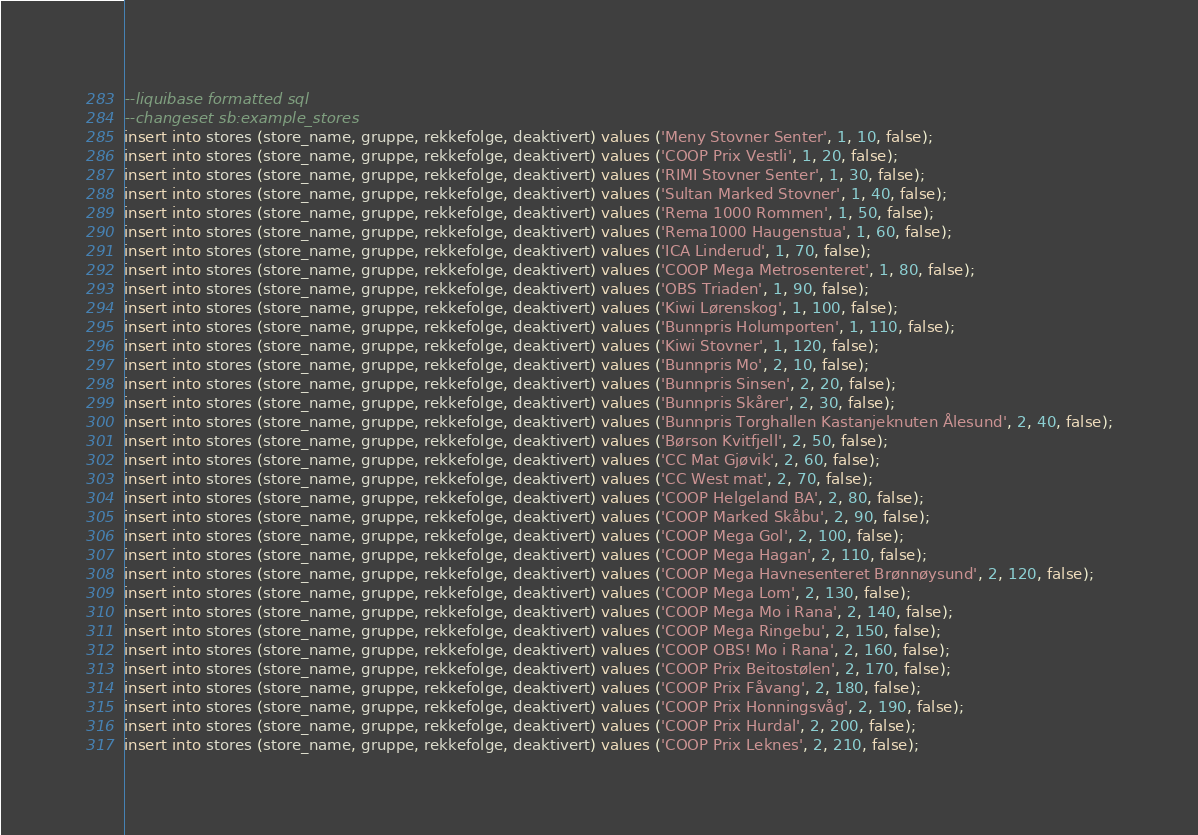Convert code to text. <code><loc_0><loc_0><loc_500><loc_500><_SQL_>--liquibase formatted sql
--changeset sb:example_stores
insert into stores (store_name, gruppe, rekkefolge, deaktivert) values ('Meny Stovner Senter', 1, 10, false);
insert into stores (store_name, gruppe, rekkefolge, deaktivert) values ('COOP Prix Vestli', 1, 20, false);
insert into stores (store_name, gruppe, rekkefolge, deaktivert) values ('RIMI Stovner Senter', 1, 30, false);
insert into stores (store_name, gruppe, rekkefolge, deaktivert) values ('Sultan Marked Stovner', 1, 40, false);
insert into stores (store_name, gruppe, rekkefolge, deaktivert) values ('Rema 1000 Rommen', 1, 50, false);
insert into stores (store_name, gruppe, rekkefolge, deaktivert) values ('Rema1000 Haugenstua', 1, 60, false);
insert into stores (store_name, gruppe, rekkefolge, deaktivert) values ('ICA Linderud', 1, 70, false);
insert into stores (store_name, gruppe, rekkefolge, deaktivert) values ('COOP Mega Metrosenteret', 1, 80, false);
insert into stores (store_name, gruppe, rekkefolge, deaktivert) values ('OBS Triaden', 1, 90, false);
insert into stores (store_name, gruppe, rekkefolge, deaktivert) values ('Kiwi Lørenskog', 1, 100, false);
insert into stores (store_name, gruppe, rekkefolge, deaktivert) values ('Bunnpris Holumporten', 1, 110, false);
insert into stores (store_name, gruppe, rekkefolge, deaktivert) values ('Kiwi Stovner', 1, 120, false);
insert into stores (store_name, gruppe, rekkefolge, deaktivert) values ('Bunnpris Mo', 2, 10, false);
insert into stores (store_name, gruppe, rekkefolge, deaktivert) values ('Bunnpris Sinsen', 2, 20, false);
insert into stores (store_name, gruppe, rekkefolge, deaktivert) values ('Bunnpris Skårer', 2, 30, false);
insert into stores (store_name, gruppe, rekkefolge, deaktivert) values ('Bunnpris Torghallen Kastanjeknuten Ålesund', 2, 40, false);
insert into stores (store_name, gruppe, rekkefolge, deaktivert) values ('Børson Kvitfjell', 2, 50, false);
insert into stores (store_name, gruppe, rekkefolge, deaktivert) values ('CC Mat Gjøvik', 2, 60, false);
insert into stores (store_name, gruppe, rekkefolge, deaktivert) values ('CC West mat', 2, 70, false);
insert into stores (store_name, gruppe, rekkefolge, deaktivert) values ('COOP Helgeland BA', 2, 80, false);
insert into stores (store_name, gruppe, rekkefolge, deaktivert) values ('COOP Marked Skåbu', 2, 90, false);
insert into stores (store_name, gruppe, rekkefolge, deaktivert) values ('COOP Mega Gol', 2, 100, false);
insert into stores (store_name, gruppe, rekkefolge, deaktivert) values ('COOP Mega Hagan', 2, 110, false);
insert into stores (store_name, gruppe, rekkefolge, deaktivert) values ('COOP Mega Havnesenteret Brønnøysund', 2, 120, false);
insert into stores (store_name, gruppe, rekkefolge, deaktivert) values ('COOP Mega Lom', 2, 130, false);
insert into stores (store_name, gruppe, rekkefolge, deaktivert) values ('COOP Mega Mo i Rana', 2, 140, false);
insert into stores (store_name, gruppe, rekkefolge, deaktivert) values ('COOP Mega Ringebu', 2, 150, false);
insert into stores (store_name, gruppe, rekkefolge, deaktivert) values ('COOP OBS! Mo i Rana', 2, 160, false);
insert into stores (store_name, gruppe, rekkefolge, deaktivert) values ('COOP Prix Beitostølen', 2, 170, false);
insert into stores (store_name, gruppe, rekkefolge, deaktivert) values ('COOP Prix Fåvang', 2, 180, false);
insert into stores (store_name, gruppe, rekkefolge, deaktivert) values ('COOP Prix Honningsvåg', 2, 190, false);
insert into stores (store_name, gruppe, rekkefolge, deaktivert) values ('COOP Prix Hurdal', 2, 200, false);
insert into stores (store_name, gruppe, rekkefolge, deaktivert) values ('COOP Prix Leknes', 2, 210, false);</code> 